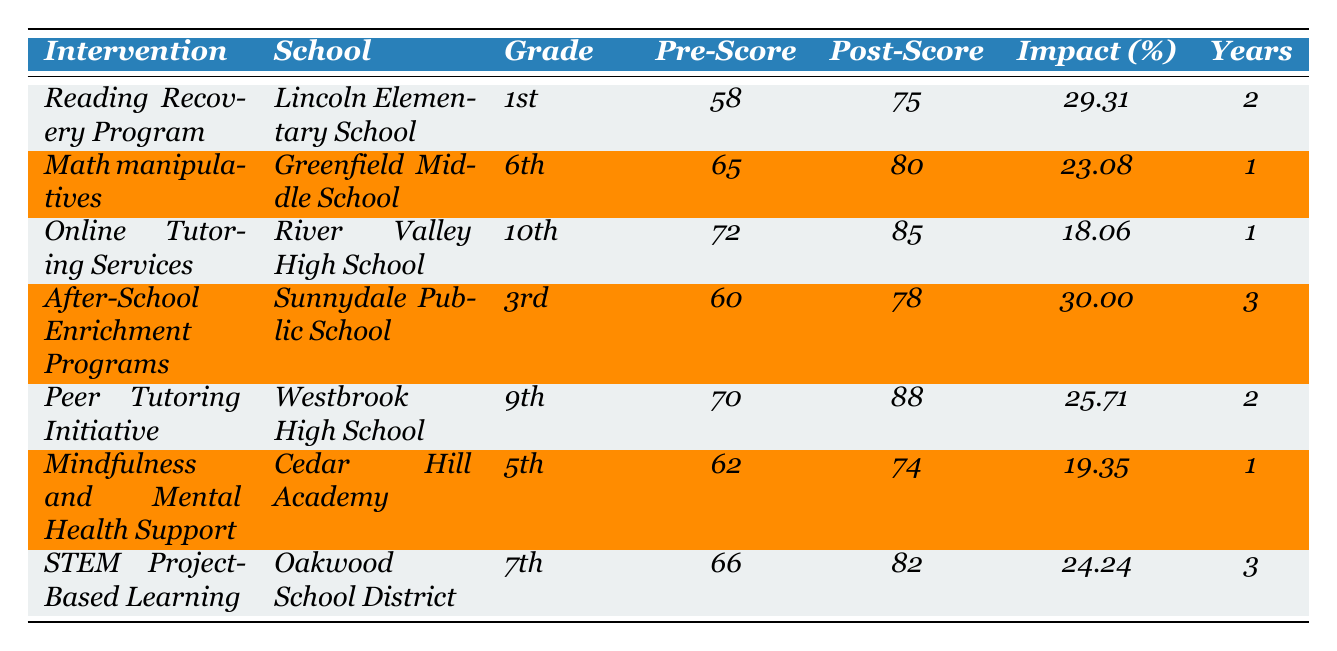What is the impact percentage of the Reading Recovery Program at Lincoln Elementary School? The table shows that the impact percentage for the Reading Recovery Program is listed under the relevant column. This value is 29.31%.
Answer: 29.31% Which intervention had the highest post-implementation average score? By looking at the post-implementation average scores in the table, the highest score can be identified. The Peer Tutoring Initiative shows a post-score of 88, which is the highest among all interventions listed.
Answer: 88 How much did the After-School Enrichment Programs improve the average score? The improvement can be calculated by taking the post-implementation score (78) and subtracting the pre-implementation score (60). Thus, 78 - 60 = 18, indicating an 18-point improvement in average score.
Answer: 18 How many years of data were collected for the STEM Project-Based Learning initiative? The table specifically lists the years of data collected for each intervention. For STEM Project-Based Learning, it states that 3 years of data were collected.
Answer: 3 Which intervention had the lowest impact percentage, and what was that percentage? By scanning the impact percentages for all interventions, the lowest value is found for Online Tutoring Services, which has an impact of 18.06%.
Answer: 18.06% Is there any intervention that resulted in a post-implementation average score below 75? Reviewing the post-implementation scores in the table, the Mindfulness and Mental Health Support received a score of 74, which is below 75. Therefore, the answer is yes.
Answer: Yes What is the average impact percentage across all the interventions listed? To find the average impact percentage, sum all the impact percentages (29.31 + 23.08 + 18.06 + 30.00 + 25.71 + 19.35 + 24.24) which equals 169.75. Then divide the sum by the number of interventions (7). Thus, the average impact percentage is 169.75/7 = 24.25.
Answer: 24.25 Did any intervention have a pre-implementation score above 70? The pre-implementation scores listed in the table can be checked. Both the Peer Tutoring Initiative (70) and Online Tutoring Services (72) exceed 70, confirming that the answer is yes.
Answer: Yes Which grade level had the greatest increase in average score after implementation? Calculating the score differences for each intervention, the After-School Enrichment Programs (18 points) and Peer Tutoring Initiative (18 points) both had the greatest increase, but since there are ties, it's more appropriate to conclude that there are multiple interventions with the highest increase of 18.
Answer: Tied (18 points) Across all interventions, what is the sum of the pre-implementation scores? The sum of pre-implementation scores can be calculated as follows: 58 + 65 + 72 + 60 + 70 + 62 + 66 = 423.
Answer: 423 